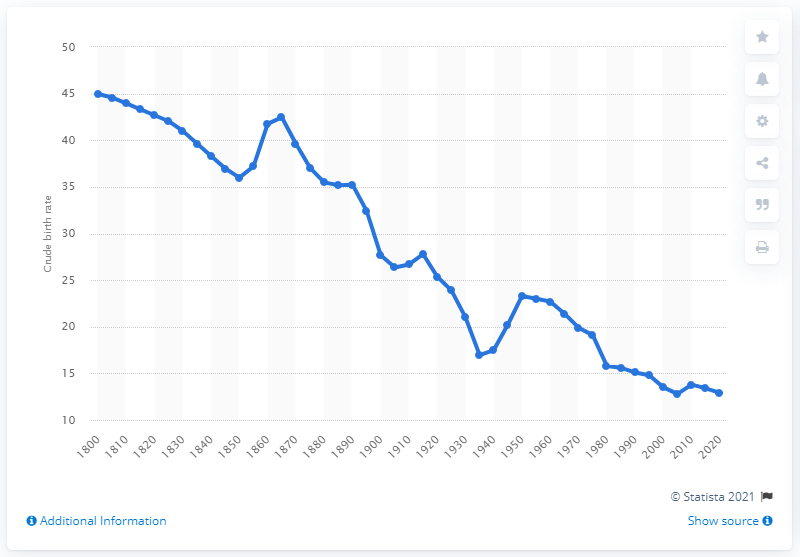List a handful of essential elements in this visual. In 1980, the birth rate in Australia was 15.8. 